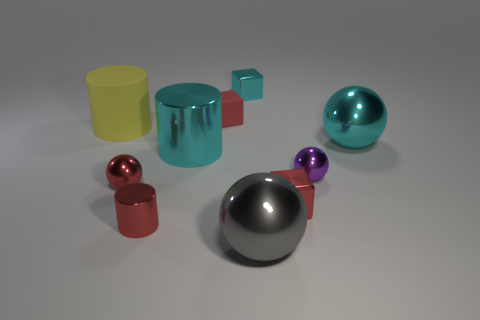Subtract all blocks. How many objects are left? 7 Subtract all shiny balls. Subtract all small red metallic cylinders. How many objects are left? 5 Add 5 cyan metal cylinders. How many cyan metal cylinders are left? 6 Add 3 tiny red metallic objects. How many tiny red metallic objects exist? 6 Subtract 0 blue cubes. How many objects are left? 10 